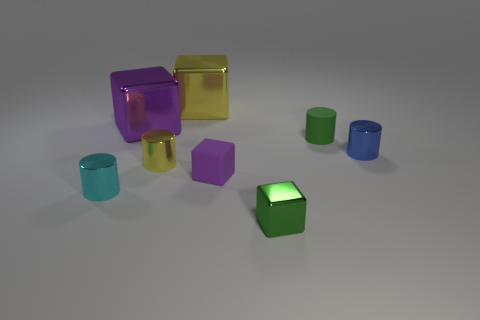Subtract all shiny cubes. How many cubes are left? 1 Subtract all green cylinders. How many cylinders are left? 3 Subtract all blue balls. How many brown blocks are left? 0 Add 2 small purple rubber things. How many small purple rubber things are left? 3 Add 6 small green cylinders. How many small green cylinders exist? 7 Add 2 cyan balls. How many objects exist? 10 Subtract 0 brown balls. How many objects are left? 8 Subtract 1 cylinders. How many cylinders are left? 3 Subtract all brown cylinders. Subtract all gray blocks. How many cylinders are left? 4 Subtract all big yellow shiny things. Subtract all metal cylinders. How many objects are left? 4 